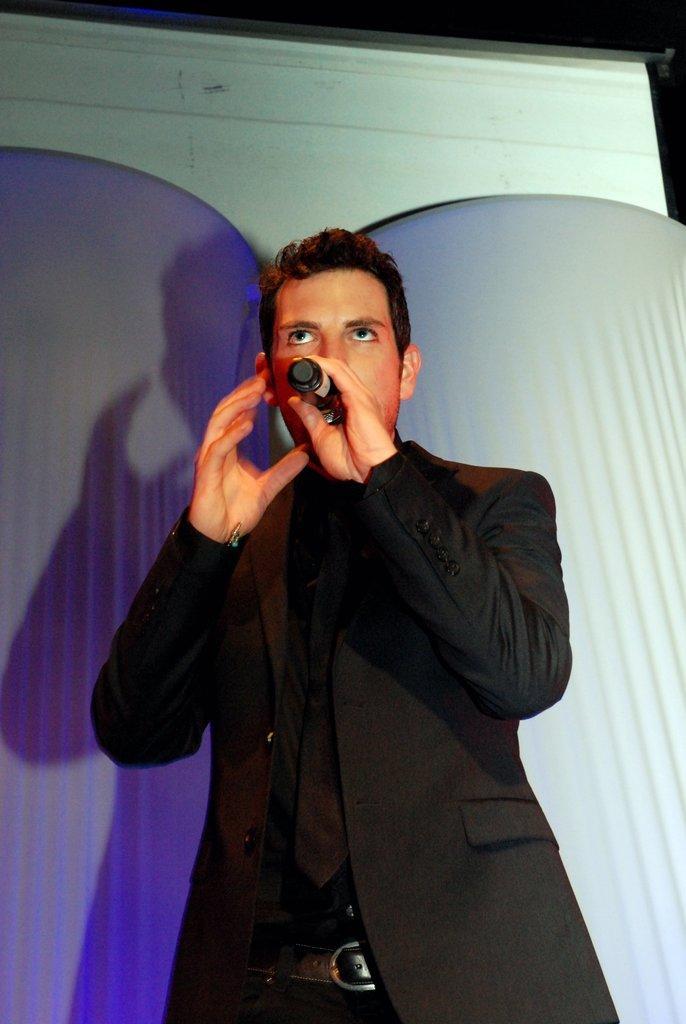Please provide a concise description of this image. Here we can see a man standing with microphone in his hand speak something 